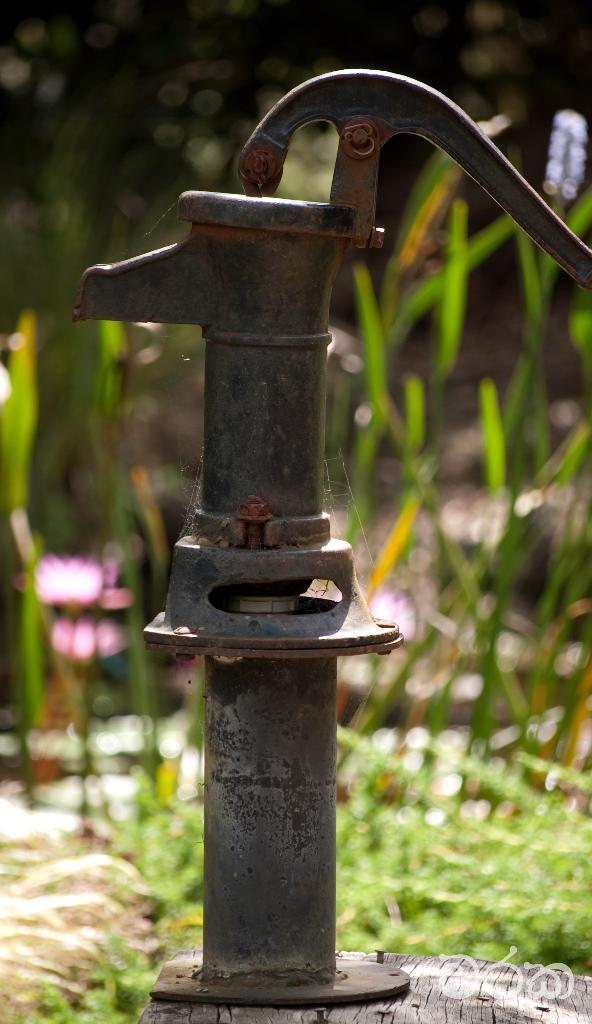What is the main object in the image? There is a hand pump in the image. What is the hand pump placed on? The hand pump is on a wooden surface. What can be seen in the background of the image? There are planets visible in the background of the image, although they appear blurred. Where is the mom standing in the image? There is no mom present in the image; it only features a hand pump and blurred planets in the background. What type of hole is visible in the image? There is no hole visible in the image; it only features a hand pump and blurred planets in the background. 